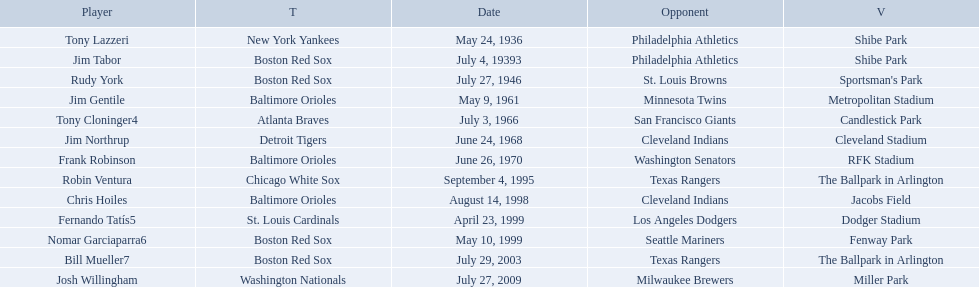Which teams played between the years 1960 and 1970? Baltimore Orioles, Atlanta Braves, Detroit Tigers, Baltimore Orioles. Of these teams that played, which ones played against the cleveland indians? Detroit Tigers. On what day did these two teams play? June 24, 1968. What are the names of all the players? Tony Lazzeri, Jim Tabor, Rudy York, Jim Gentile, Tony Cloninger4, Jim Northrup, Frank Robinson, Robin Ventura, Chris Hoiles, Fernando Tatís5, Nomar Garciaparra6, Bill Mueller7, Josh Willingham. What are the names of all the teams holding home run records? New York Yankees, Boston Red Sox, Baltimore Orioles, Atlanta Braves, Detroit Tigers, Chicago White Sox, St. Louis Cardinals, Washington Nationals. Which player played for the new york yankees? Tony Lazzeri. Who were all of the players? Tony Lazzeri, Jim Tabor, Rudy York, Jim Gentile, Tony Cloninger4, Jim Northrup, Frank Robinson, Robin Ventura, Chris Hoiles, Fernando Tatís5, Nomar Garciaparra6, Bill Mueller7, Josh Willingham. What year was there a player for the yankees? May 24, 1936. What was the name of that 1936 yankees player? Tony Lazzeri. 